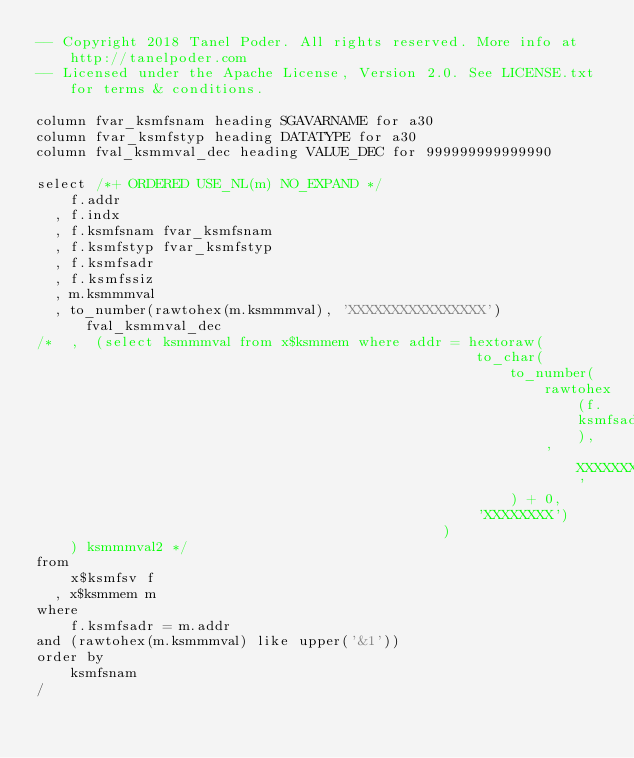<code> <loc_0><loc_0><loc_500><loc_500><_SQL_>-- Copyright 2018 Tanel Poder. All rights reserved. More info at http://tanelpoder.com
-- Licensed under the Apache License, Version 2.0. See LICENSE.txt for terms & conditions.

column fvar_ksmfsnam heading SGAVARNAME for a30
column fvar_ksmfstyp heading DATATYPE for a30
column fval_ksmmval_dec heading VALUE_DEC for 999999999999990

select /*+ ORDERED USE_NL(m) NO_EXPAND */
    f.addr
  , f.indx
  , f.ksmfsnam fvar_ksmfsnam
  , f.ksmfstyp fvar_ksmfstyp
  , f.ksmfsadr
  , f.ksmfssiz
  , m.ksmmmval
  , to_number(rawtohex(m.ksmmmval), 'XXXXXXXXXXXXXXXX') fval_ksmmval_dec
/*  ,  (select ksmmmval from x$ksmmem where addr = hextoraw(
                                                    to_char(
                                                        to_number(
                                                            rawtohex(f.ksmfsadr),
                                                            'XXXXXXXX'
                                                        ) + 0,
                                                    'XXXXXXXX')
                                                ) 
    ) ksmmmval2 */
from
    x$ksmfsv f
  , x$ksmmem m
where
    f.ksmfsadr = m.addr
and (rawtohex(m.ksmmmval) like upper('&1'))
order by
    ksmfsnam
/
</code> 